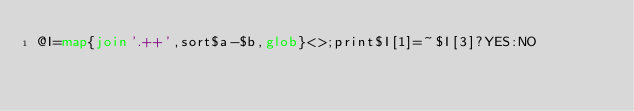<code> <loc_0><loc_0><loc_500><loc_500><_Perl_>@I=map{join'.++',sort$a-$b,glob}<>;print$I[1]=~$I[3]?YES:NO</code> 